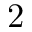Convert formula to latex. <formula><loc_0><loc_0><loc_500><loc_500>2</formula> 